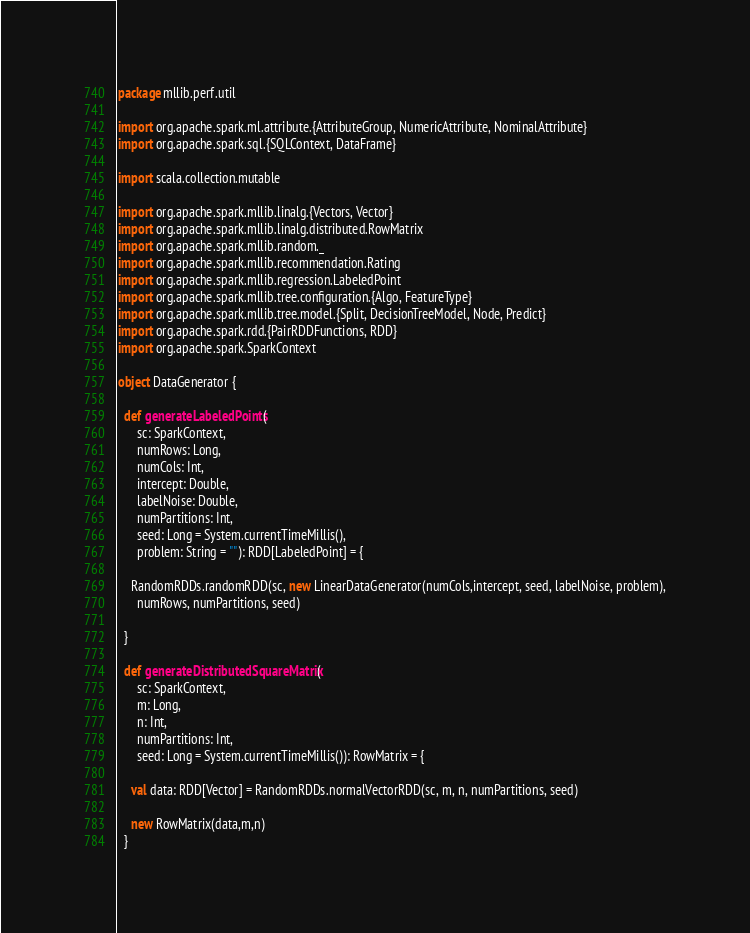<code> <loc_0><loc_0><loc_500><loc_500><_Scala_>package mllib.perf.util

import org.apache.spark.ml.attribute.{AttributeGroup, NumericAttribute, NominalAttribute}
import org.apache.spark.sql.{SQLContext, DataFrame}

import scala.collection.mutable

import org.apache.spark.mllib.linalg.{Vectors, Vector}
import org.apache.spark.mllib.linalg.distributed.RowMatrix
import org.apache.spark.mllib.random._
import org.apache.spark.mllib.recommendation.Rating
import org.apache.spark.mllib.regression.LabeledPoint
import org.apache.spark.mllib.tree.configuration.{Algo, FeatureType}
import org.apache.spark.mllib.tree.model.{Split, DecisionTreeModel, Node, Predict}
import org.apache.spark.rdd.{PairRDDFunctions, RDD}
import org.apache.spark.SparkContext

object DataGenerator {

  def generateLabeledPoints(
      sc: SparkContext,
      numRows: Long,
      numCols: Int,
      intercept: Double,
      labelNoise: Double,
      numPartitions: Int,
      seed: Long = System.currentTimeMillis(),
      problem: String = ""): RDD[LabeledPoint] = {

    RandomRDDs.randomRDD(sc, new LinearDataGenerator(numCols,intercept, seed, labelNoise, problem),
      numRows, numPartitions, seed)

  }

  def generateDistributedSquareMatrix(
      sc: SparkContext,
      m: Long,
      n: Int,
      numPartitions: Int,
      seed: Long = System.currentTimeMillis()): RowMatrix = {

    val data: RDD[Vector] = RandomRDDs.normalVectorRDD(sc, m, n, numPartitions, seed)

    new RowMatrix(data,m,n)
  }
</code> 